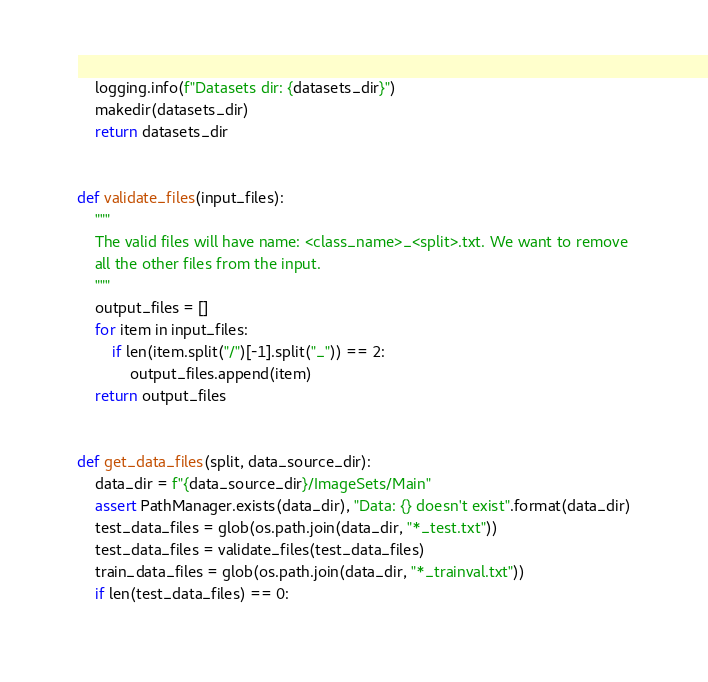<code> <loc_0><loc_0><loc_500><loc_500><_Python_>    logging.info(f"Datasets dir: {datasets_dir}")
    makedir(datasets_dir)
    return datasets_dir


def validate_files(input_files):
    """
    The valid files will have name: <class_name>_<split>.txt. We want to remove
    all the other files from the input.
    """
    output_files = []
    for item in input_files:
        if len(item.split("/")[-1].split("_")) == 2:
            output_files.append(item)
    return output_files


def get_data_files(split, data_source_dir):
    data_dir = f"{data_source_dir}/ImageSets/Main"
    assert PathManager.exists(data_dir), "Data: {} doesn't exist".format(data_dir)
    test_data_files = glob(os.path.join(data_dir, "*_test.txt"))
    test_data_files = validate_files(test_data_files)
    train_data_files = glob(os.path.join(data_dir, "*_trainval.txt"))
    if len(test_data_files) == 0:</code> 